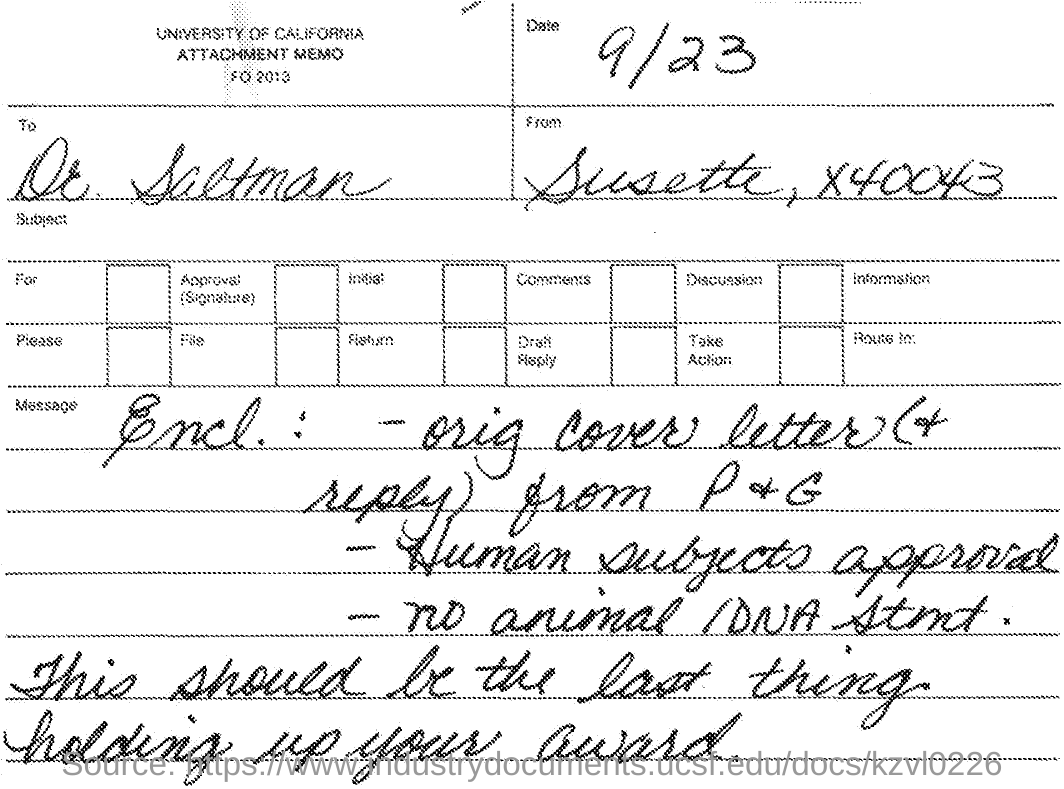What is the date mentioned ?
Provide a short and direct response. 9/23. To whom this letter is sent ?
Ensure brevity in your answer.  Dr. Saltman. From whom this letter is sent
Your response must be concise. Susette, X40043. What is the name of the university mentioned ?
Offer a very short reply. UNIVERSITY OF CALIFORNIA. 